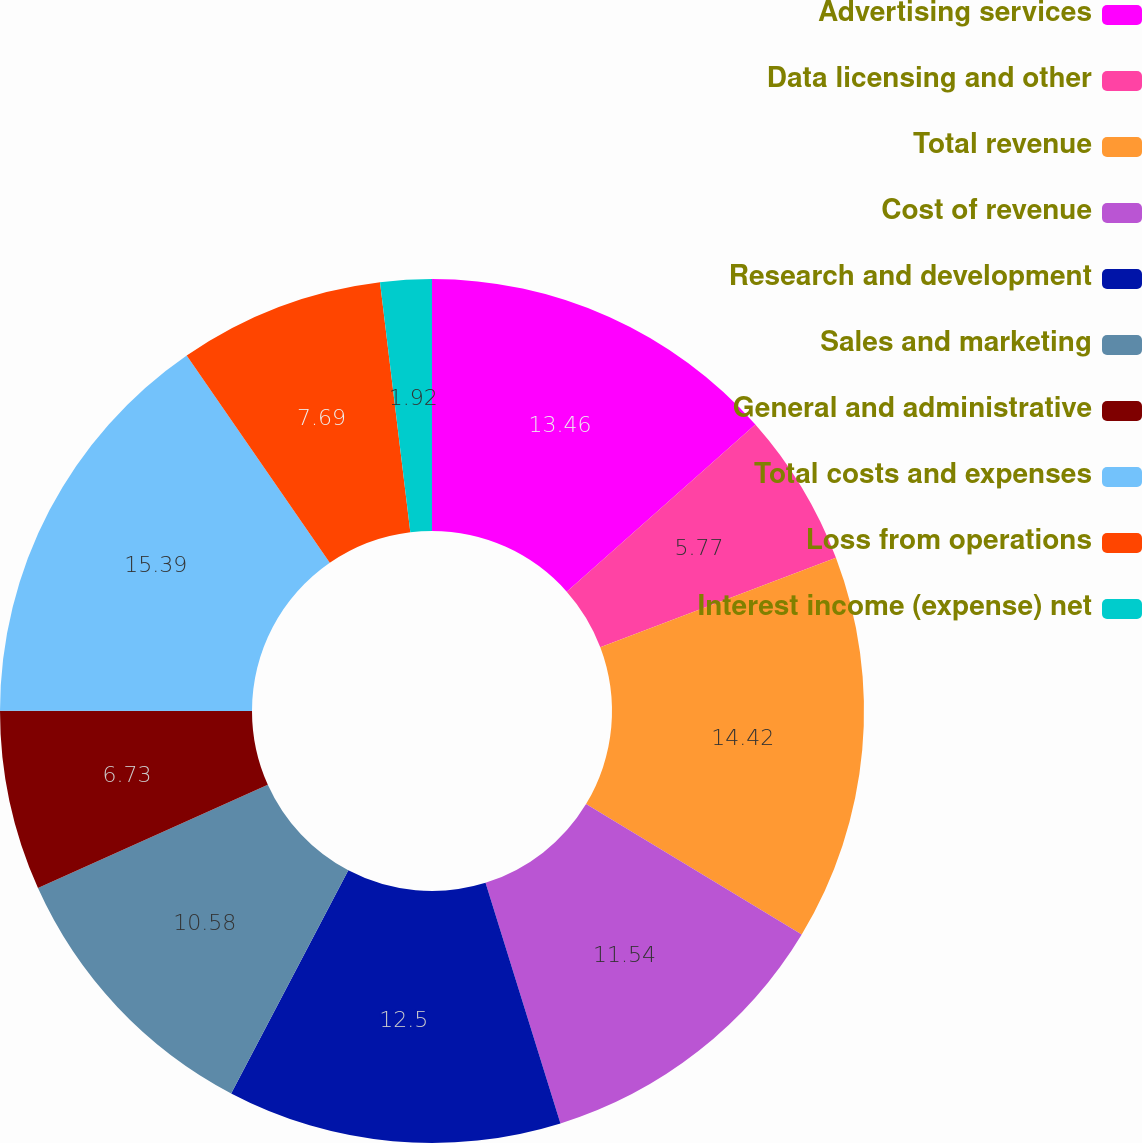<chart> <loc_0><loc_0><loc_500><loc_500><pie_chart><fcel>Advertising services<fcel>Data licensing and other<fcel>Total revenue<fcel>Cost of revenue<fcel>Research and development<fcel>Sales and marketing<fcel>General and administrative<fcel>Total costs and expenses<fcel>Loss from operations<fcel>Interest income (expense) net<nl><fcel>13.46%<fcel>5.77%<fcel>14.42%<fcel>11.54%<fcel>12.5%<fcel>10.58%<fcel>6.73%<fcel>15.38%<fcel>7.69%<fcel>1.92%<nl></chart> 